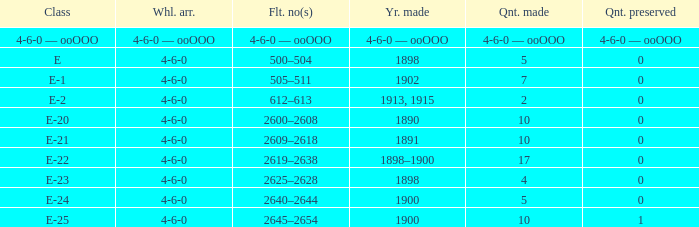What is the volume created of the e-22 class, which has a conserved volume of 0? 17.0. 